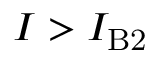<formula> <loc_0><loc_0><loc_500><loc_500>I > I _ { B 2 }</formula> 